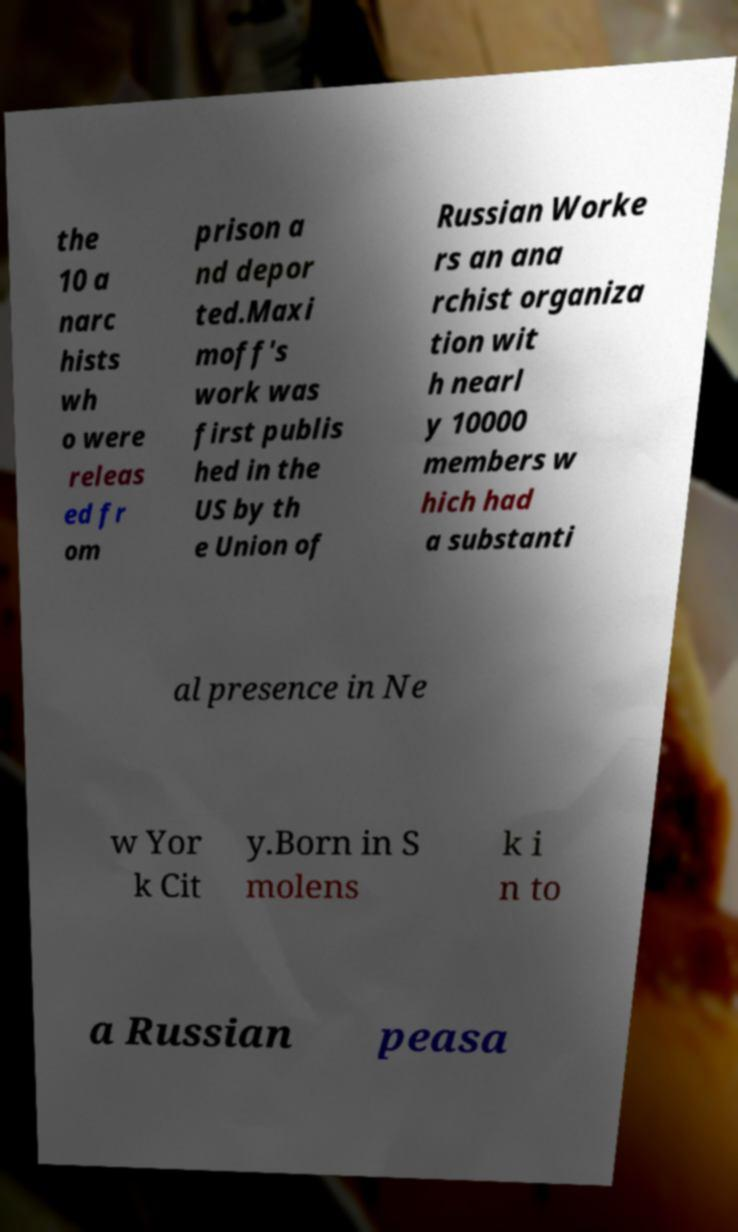I need the written content from this picture converted into text. Can you do that? the 10 a narc hists wh o were releas ed fr om prison a nd depor ted.Maxi moff's work was first publis hed in the US by th e Union of Russian Worke rs an ana rchist organiza tion wit h nearl y 10000 members w hich had a substanti al presence in Ne w Yor k Cit y.Born in S molens k i n to a Russian peasa 